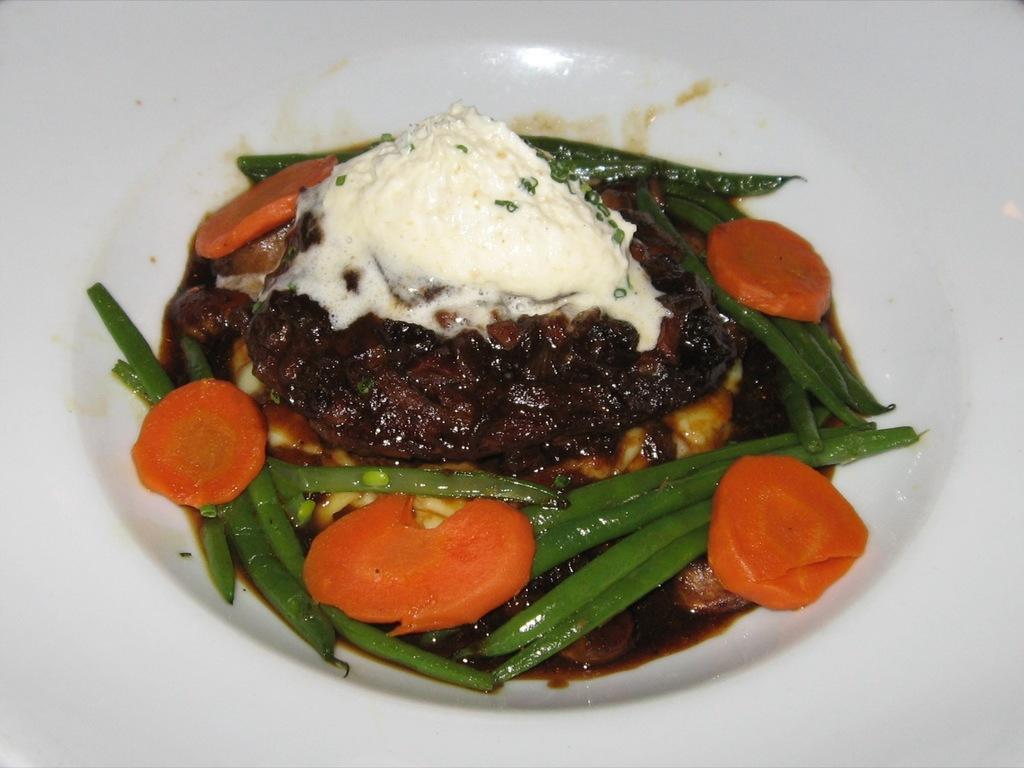How would you summarize this image in a sentence or two? This image consists of a plate. It is in white color. On that there are some eatables, such are carrots, ice cream, meat beans. 